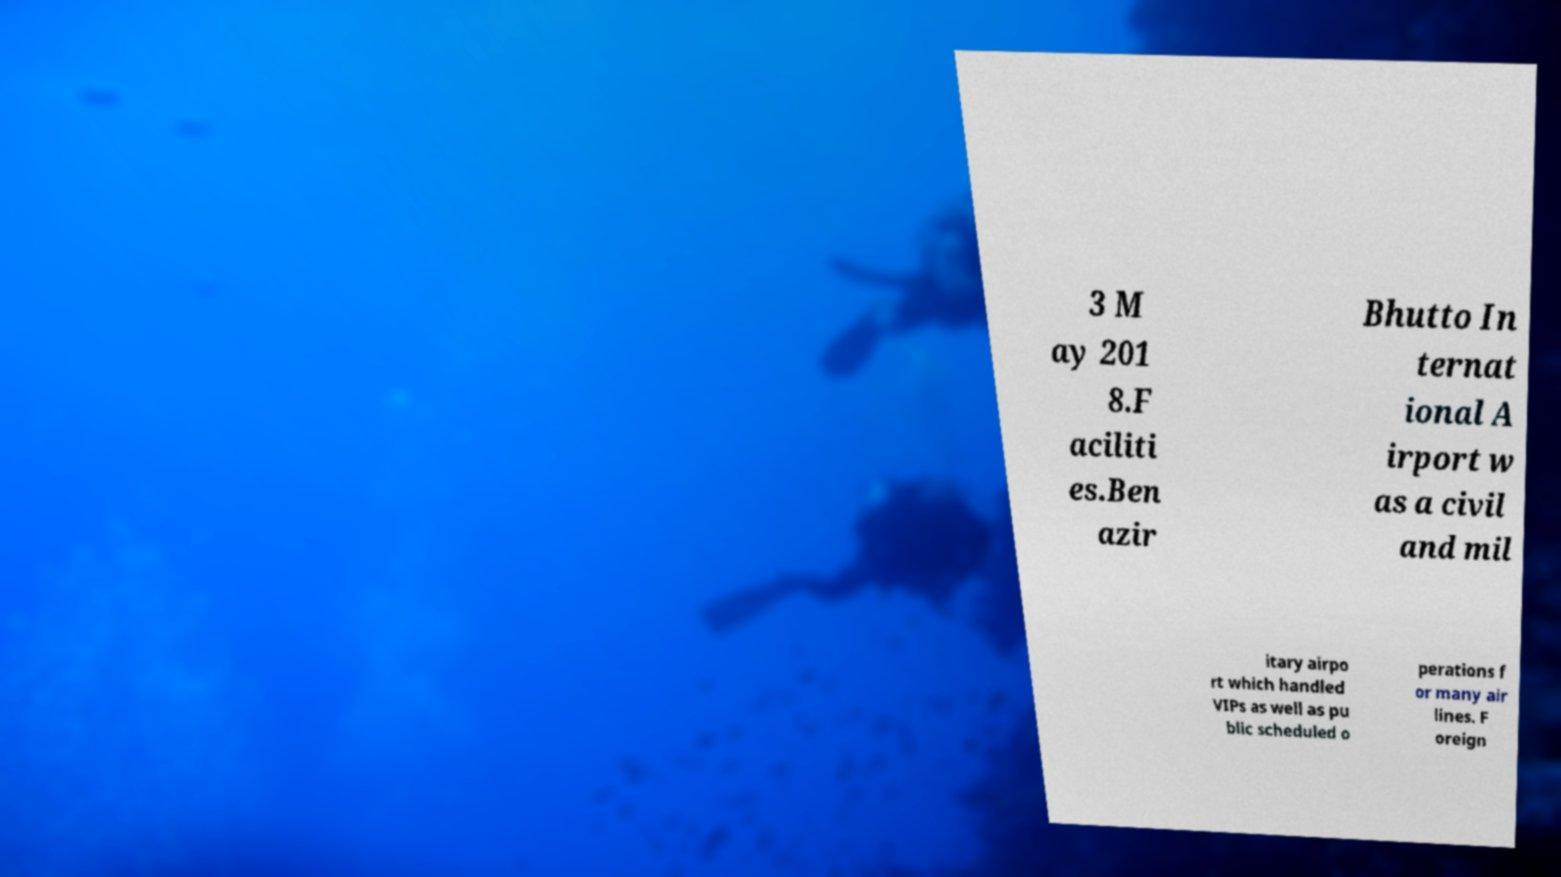Could you assist in decoding the text presented in this image and type it out clearly? 3 M ay 201 8.F aciliti es.Ben azir Bhutto In ternat ional A irport w as a civil and mil itary airpo rt which handled VIPs as well as pu blic scheduled o perations f or many air lines. F oreign 